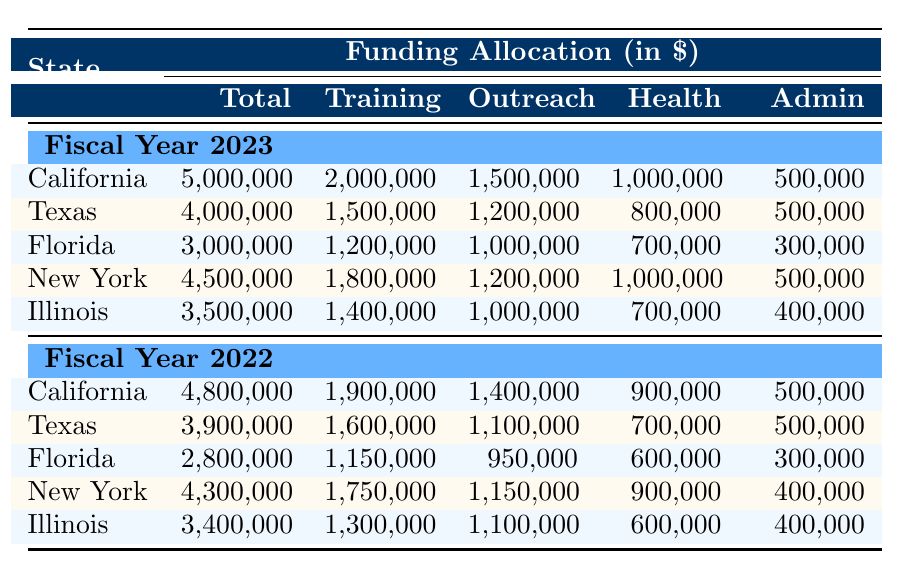What is the total funding allocated for California in 2023? The total funding for California in 2023 is directly stated in the table under Fiscal Year 2023, in the row for California. The value listed is 5,000,000.
Answer: 5,000,000 Which state received the highest funding in 2022? To find the highest funding in 2022, we compare the total funding for each state listed under Fiscal Year 2022. The values are: California 4,800,000, Texas 3,900,000, Florida 2,800,000, New York 4,300,000, and Illinois 3,400,000. The highest is California with 4,800,000.
Answer: California What is the difference in training funding between Florida in 2023 and 2022? The funding for Training and Development in Florida for 2023 is 1,200,000, and for 2022 it is 1,150,000. To find the difference, we subtract the 2022 funding from 2023 funding: 1,200,000 - 1,150,000 = 50,000.
Answer: 50,000 Is the funding for Health and Wellness in Texas greater than in Illinois for 2023? The Health and Wellness funding for Texas in 2023 is 800,000, and for Illinois, it is 700,000. Since 800,000 is greater than 700,000, the statement is true.
Answer: Yes What is the average total funding for the states listed in 2023? The total funding for the states in 2023 are: California 5,000,000, Texas 4,000,000, Florida 3,000,000, New York 4,500,000, Illinois 3,500,000. To find the average, we sum these values: 5,000,000 + 4,000,000 + 3,000,000 + 4,500,000 + 3,500,000 = 20,000,000. There are 5 states, so the average is 20,000,000 / 5 = 4,000,000.
Answer: 4,000,000 What was the total funding for Community Outreach in New York in 2022? The Community Outreach funding for New York in 2022 is clearly indicated in the table in the row for New York and under the Fiscal Year 2022 section. The value is 1,150,000.
Answer: 1,150,000 